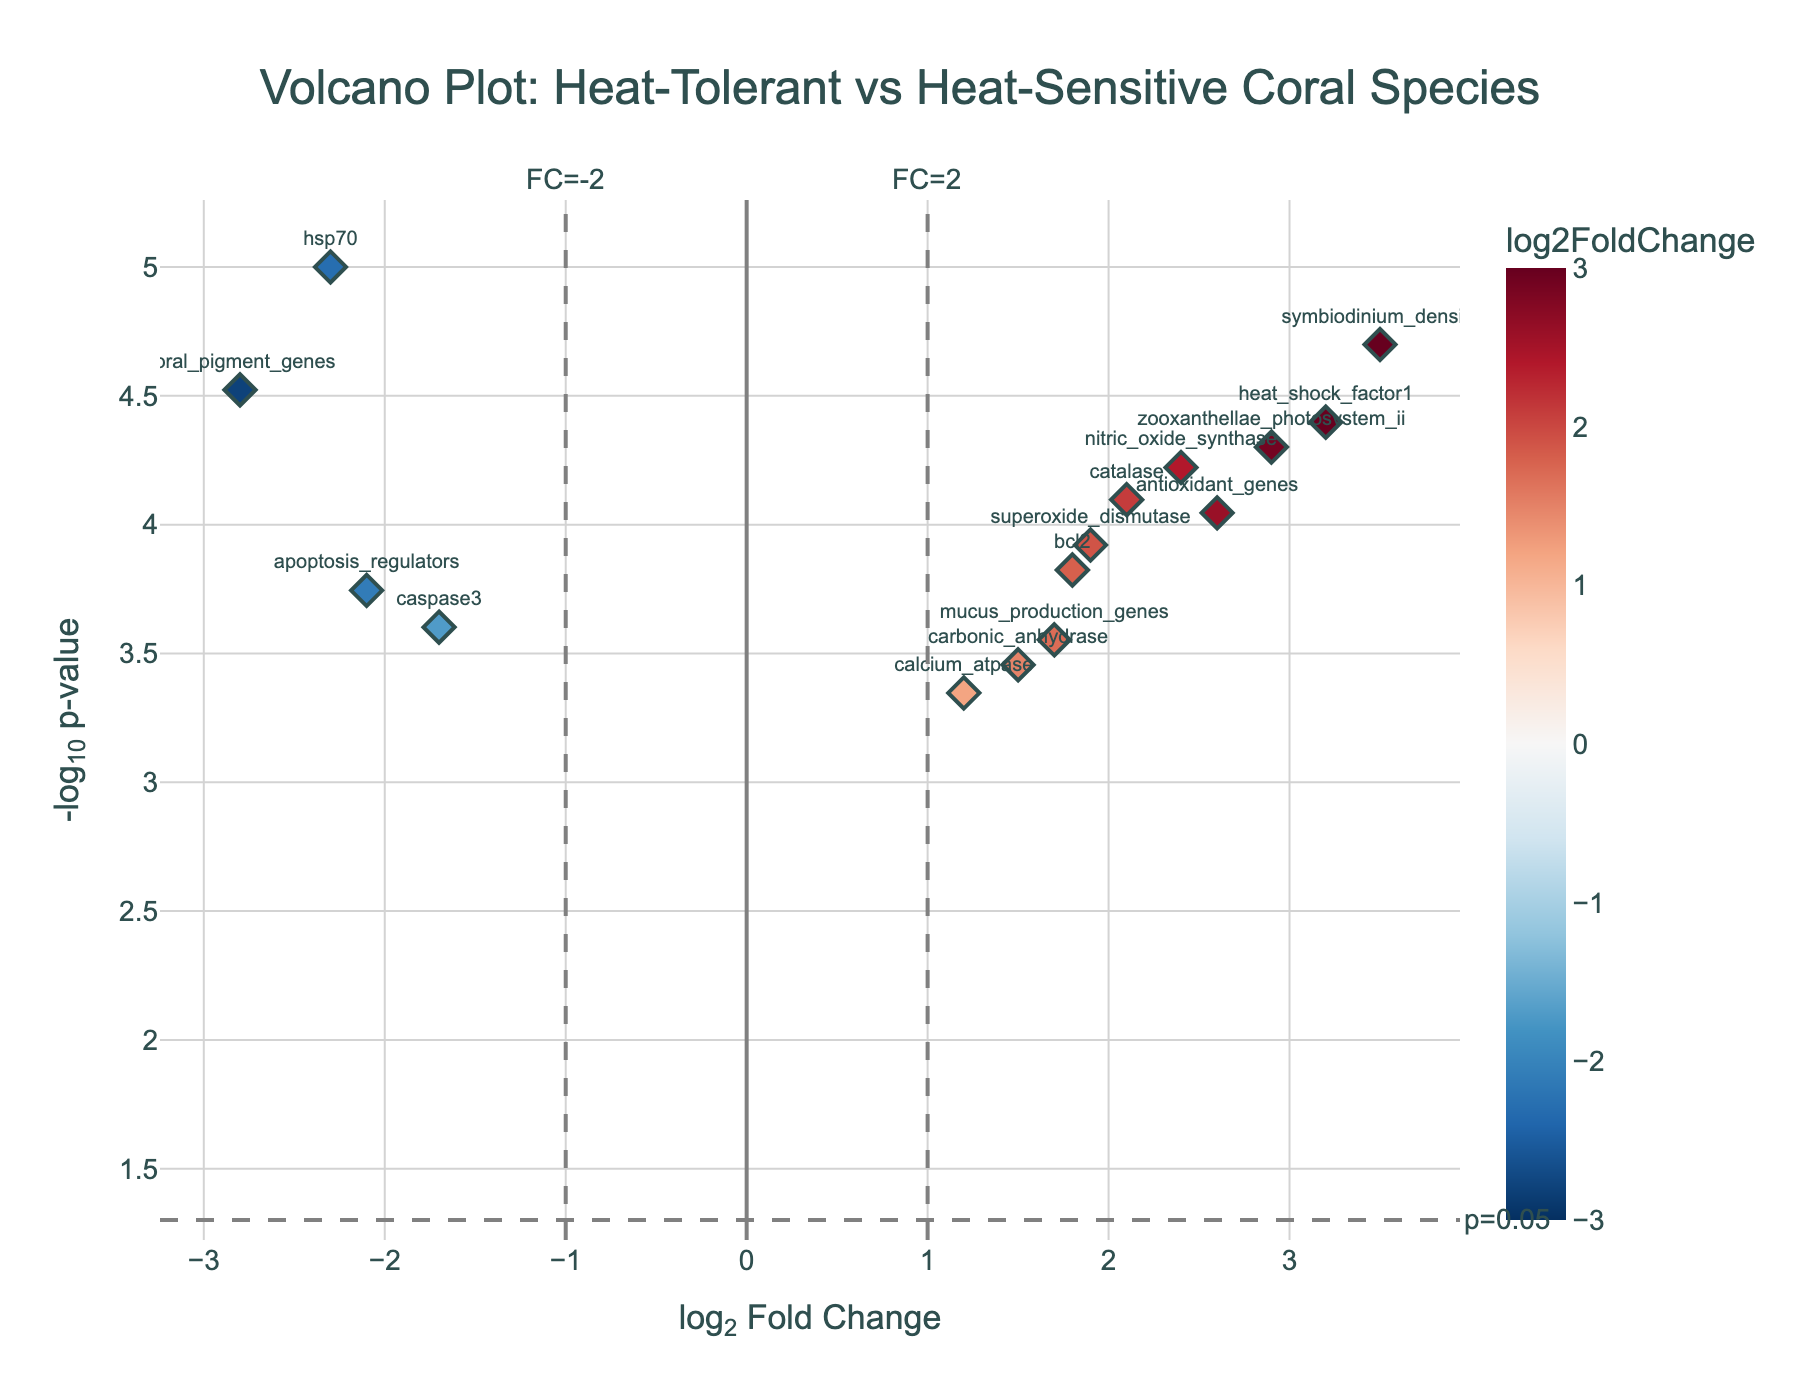How many genes are displayed in the plot? There are 15 data points corresponding to 15 different genes listed in the data
Answer: 15 Which gene has the highest log2 fold change? The gene with the highest log2 fold change is 'symbiodinium_density' with a log2 fold change of 3.5 as mentioned in the column of the dataset
Answer: symbiodinium_density What is the p-value threshold indicated by the horizontal dashed line? The horizontal dashed line represents the threshold at -log10(p-value) equal to -log10(0.05). Calculating -log10(0.05) gives approximately 1.30
Answer: 0.05 Which genes are upregulated with a -log10(p-value) greater than 3? Upregulated genes have a positive log2 fold change. The genes with a -log10(p-value) greater than 3 include 'symbiodinium_density' (log2FoldChange=3.5) and 'heat_shock_factor1' (log2FoldChange=3.2)
Answer: symbiodinium_density, heat_shock_factor1 What is the range of log2 fold changes in the plot? The range of log2 fold changes is determined by the minimum and maximum values in the dataset. With 'calcium_atpase' (min=1.2) and 'symbiodinium_density' (max=3.5), so range is (3.5) - (1.2) = 2.3
Answer: 2.3 Which low p-value gene is downregulated with the highest fold change? The low p-value gene ('coral_pigment_genes' with a p-value=0.00003) is downregulated with the highest log2 fold change =-2.8
Answer: coral_pigment_genes How many genes have a log2 fold change greater than 2? By counting the data points with a log2 fold change greater than 2 ('symbiodinium_density', 'catalase', 'heat_shock_factor1', 'antioxidant_genes'), there are 4 such genes
Answer: 4 What does the color gradient in the plot represent? The color gradient (RdBu_r) in the plot indicates the log2 fold change values, spanning from blue (downregulated) to red (upregulated)
Answer: log2 fold change values Which genes are close to the vertical threshold lines, and what does it indicate? Genes 'carbonic_anhydrase' and 'calcium_atpase' are close to the vertical threshold lines (FC=2 and FC=-2), indicating these genes are minimally differentially expressed near the significance threshold
Answer: carbonic_anhydrase, calcium_atpase 